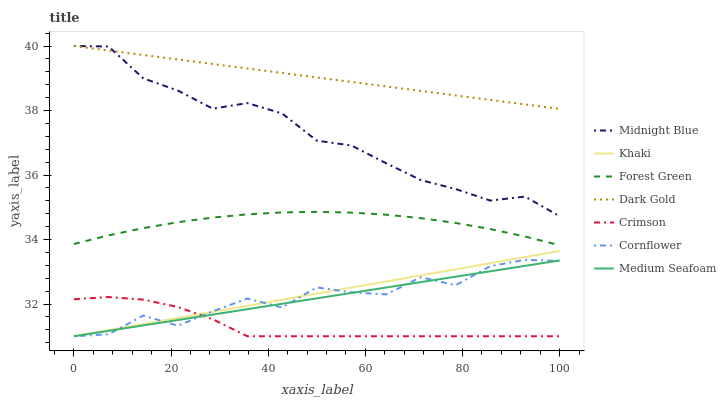Does Crimson have the minimum area under the curve?
Answer yes or no. Yes. Does Dark Gold have the maximum area under the curve?
Answer yes or no. Yes. Does Khaki have the minimum area under the curve?
Answer yes or no. No. Does Khaki have the maximum area under the curve?
Answer yes or no. No. Is Khaki the smoothest?
Answer yes or no. Yes. Is Cornflower the roughest?
Answer yes or no. Yes. Is Midnight Blue the smoothest?
Answer yes or no. No. Is Midnight Blue the roughest?
Answer yes or no. No. Does Cornflower have the lowest value?
Answer yes or no. Yes. Does Midnight Blue have the lowest value?
Answer yes or no. No. Does Dark Gold have the highest value?
Answer yes or no. Yes. Does Khaki have the highest value?
Answer yes or no. No. Is Crimson less than Dark Gold?
Answer yes or no. Yes. Is Dark Gold greater than Cornflower?
Answer yes or no. Yes. Does Crimson intersect Khaki?
Answer yes or no. Yes. Is Crimson less than Khaki?
Answer yes or no. No. Is Crimson greater than Khaki?
Answer yes or no. No. Does Crimson intersect Dark Gold?
Answer yes or no. No. 